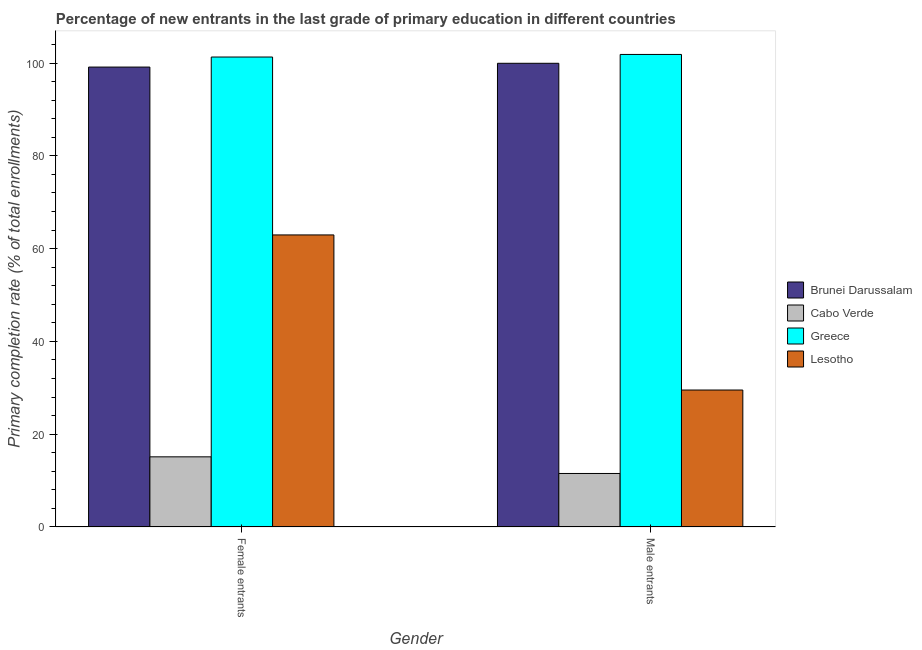How many different coloured bars are there?
Give a very brief answer. 4. How many groups of bars are there?
Provide a succinct answer. 2. How many bars are there on the 1st tick from the left?
Provide a succinct answer. 4. What is the label of the 1st group of bars from the left?
Ensure brevity in your answer.  Female entrants. What is the primary completion rate of female entrants in Greece?
Offer a terse response. 101.31. Across all countries, what is the maximum primary completion rate of female entrants?
Make the answer very short. 101.31. Across all countries, what is the minimum primary completion rate of female entrants?
Offer a very short reply. 15.12. In which country was the primary completion rate of male entrants minimum?
Ensure brevity in your answer.  Cabo Verde. What is the total primary completion rate of female entrants in the graph?
Provide a succinct answer. 278.52. What is the difference between the primary completion rate of male entrants in Greece and that in Cabo Verde?
Your answer should be very brief. 90.32. What is the difference between the primary completion rate of female entrants in Brunei Darussalam and the primary completion rate of male entrants in Lesotho?
Keep it short and to the point. 69.61. What is the average primary completion rate of female entrants per country?
Give a very brief answer. 69.63. What is the difference between the primary completion rate of female entrants and primary completion rate of male entrants in Lesotho?
Your answer should be very brief. 33.43. In how many countries, is the primary completion rate of male entrants greater than 92 %?
Provide a succinct answer. 2. What is the ratio of the primary completion rate of female entrants in Cabo Verde to that in Brunei Darussalam?
Make the answer very short. 0.15. In how many countries, is the primary completion rate of male entrants greater than the average primary completion rate of male entrants taken over all countries?
Your answer should be very brief. 2. What does the 4th bar from the left in Female entrants represents?
Ensure brevity in your answer.  Lesotho. What does the 1st bar from the right in Female entrants represents?
Offer a terse response. Lesotho. Does the graph contain any zero values?
Offer a very short reply. No. Does the graph contain grids?
Provide a succinct answer. No. Where does the legend appear in the graph?
Provide a short and direct response. Center right. How many legend labels are there?
Your response must be concise. 4. What is the title of the graph?
Offer a terse response. Percentage of new entrants in the last grade of primary education in different countries. What is the label or title of the X-axis?
Keep it short and to the point. Gender. What is the label or title of the Y-axis?
Make the answer very short. Primary completion rate (% of total enrollments). What is the Primary completion rate (% of total enrollments) in Brunei Darussalam in Female entrants?
Your response must be concise. 99.14. What is the Primary completion rate (% of total enrollments) of Cabo Verde in Female entrants?
Provide a succinct answer. 15.12. What is the Primary completion rate (% of total enrollments) in Greece in Female entrants?
Give a very brief answer. 101.31. What is the Primary completion rate (% of total enrollments) in Lesotho in Female entrants?
Offer a terse response. 62.96. What is the Primary completion rate (% of total enrollments) in Brunei Darussalam in Male entrants?
Your answer should be very brief. 99.95. What is the Primary completion rate (% of total enrollments) of Cabo Verde in Male entrants?
Keep it short and to the point. 11.54. What is the Primary completion rate (% of total enrollments) in Greece in Male entrants?
Offer a terse response. 101.86. What is the Primary completion rate (% of total enrollments) of Lesotho in Male entrants?
Your response must be concise. 29.53. Across all Gender, what is the maximum Primary completion rate (% of total enrollments) of Brunei Darussalam?
Ensure brevity in your answer.  99.95. Across all Gender, what is the maximum Primary completion rate (% of total enrollments) in Cabo Verde?
Your answer should be very brief. 15.12. Across all Gender, what is the maximum Primary completion rate (% of total enrollments) of Greece?
Keep it short and to the point. 101.86. Across all Gender, what is the maximum Primary completion rate (% of total enrollments) in Lesotho?
Your answer should be compact. 62.96. Across all Gender, what is the minimum Primary completion rate (% of total enrollments) in Brunei Darussalam?
Your answer should be compact. 99.14. Across all Gender, what is the minimum Primary completion rate (% of total enrollments) in Cabo Verde?
Provide a succinct answer. 11.54. Across all Gender, what is the minimum Primary completion rate (% of total enrollments) of Greece?
Your answer should be compact. 101.31. Across all Gender, what is the minimum Primary completion rate (% of total enrollments) of Lesotho?
Offer a very short reply. 29.53. What is the total Primary completion rate (% of total enrollments) in Brunei Darussalam in the graph?
Give a very brief answer. 199.09. What is the total Primary completion rate (% of total enrollments) in Cabo Verde in the graph?
Make the answer very short. 26.66. What is the total Primary completion rate (% of total enrollments) of Greece in the graph?
Provide a short and direct response. 203.16. What is the total Primary completion rate (% of total enrollments) in Lesotho in the graph?
Ensure brevity in your answer.  92.48. What is the difference between the Primary completion rate (% of total enrollments) in Brunei Darussalam in Female entrants and that in Male entrants?
Offer a terse response. -0.82. What is the difference between the Primary completion rate (% of total enrollments) of Cabo Verde in Female entrants and that in Male entrants?
Offer a very short reply. 3.59. What is the difference between the Primary completion rate (% of total enrollments) of Greece in Female entrants and that in Male entrants?
Your answer should be compact. -0.55. What is the difference between the Primary completion rate (% of total enrollments) in Lesotho in Female entrants and that in Male entrants?
Keep it short and to the point. 33.43. What is the difference between the Primary completion rate (% of total enrollments) in Brunei Darussalam in Female entrants and the Primary completion rate (% of total enrollments) in Cabo Verde in Male entrants?
Provide a short and direct response. 87.6. What is the difference between the Primary completion rate (% of total enrollments) of Brunei Darussalam in Female entrants and the Primary completion rate (% of total enrollments) of Greece in Male entrants?
Provide a succinct answer. -2.72. What is the difference between the Primary completion rate (% of total enrollments) of Brunei Darussalam in Female entrants and the Primary completion rate (% of total enrollments) of Lesotho in Male entrants?
Provide a short and direct response. 69.61. What is the difference between the Primary completion rate (% of total enrollments) of Cabo Verde in Female entrants and the Primary completion rate (% of total enrollments) of Greece in Male entrants?
Provide a short and direct response. -86.73. What is the difference between the Primary completion rate (% of total enrollments) in Cabo Verde in Female entrants and the Primary completion rate (% of total enrollments) in Lesotho in Male entrants?
Make the answer very short. -14.4. What is the difference between the Primary completion rate (% of total enrollments) of Greece in Female entrants and the Primary completion rate (% of total enrollments) of Lesotho in Male entrants?
Your response must be concise. 71.78. What is the average Primary completion rate (% of total enrollments) in Brunei Darussalam per Gender?
Your answer should be compact. 99.55. What is the average Primary completion rate (% of total enrollments) in Cabo Verde per Gender?
Offer a very short reply. 13.33. What is the average Primary completion rate (% of total enrollments) in Greece per Gender?
Offer a terse response. 101.58. What is the average Primary completion rate (% of total enrollments) of Lesotho per Gender?
Your answer should be very brief. 46.24. What is the difference between the Primary completion rate (% of total enrollments) of Brunei Darussalam and Primary completion rate (% of total enrollments) of Cabo Verde in Female entrants?
Give a very brief answer. 84.01. What is the difference between the Primary completion rate (% of total enrollments) of Brunei Darussalam and Primary completion rate (% of total enrollments) of Greece in Female entrants?
Your response must be concise. -2.17. What is the difference between the Primary completion rate (% of total enrollments) in Brunei Darussalam and Primary completion rate (% of total enrollments) in Lesotho in Female entrants?
Offer a very short reply. 36.18. What is the difference between the Primary completion rate (% of total enrollments) of Cabo Verde and Primary completion rate (% of total enrollments) of Greece in Female entrants?
Give a very brief answer. -86.18. What is the difference between the Primary completion rate (% of total enrollments) in Cabo Verde and Primary completion rate (% of total enrollments) in Lesotho in Female entrants?
Ensure brevity in your answer.  -47.83. What is the difference between the Primary completion rate (% of total enrollments) of Greece and Primary completion rate (% of total enrollments) of Lesotho in Female entrants?
Ensure brevity in your answer.  38.35. What is the difference between the Primary completion rate (% of total enrollments) in Brunei Darussalam and Primary completion rate (% of total enrollments) in Cabo Verde in Male entrants?
Ensure brevity in your answer.  88.42. What is the difference between the Primary completion rate (% of total enrollments) of Brunei Darussalam and Primary completion rate (% of total enrollments) of Greece in Male entrants?
Make the answer very short. -1.91. What is the difference between the Primary completion rate (% of total enrollments) in Brunei Darussalam and Primary completion rate (% of total enrollments) in Lesotho in Male entrants?
Ensure brevity in your answer.  70.43. What is the difference between the Primary completion rate (% of total enrollments) in Cabo Verde and Primary completion rate (% of total enrollments) in Greece in Male entrants?
Offer a terse response. -90.32. What is the difference between the Primary completion rate (% of total enrollments) in Cabo Verde and Primary completion rate (% of total enrollments) in Lesotho in Male entrants?
Provide a short and direct response. -17.99. What is the difference between the Primary completion rate (% of total enrollments) of Greece and Primary completion rate (% of total enrollments) of Lesotho in Male entrants?
Your answer should be compact. 72.33. What is the ratio of the Primary completion rate (% of total enrollments) of Brunei Darussalam in Female entrants to that in Male entrants?
Your answer should be very brief. 0.99. What is the ratio of the Primary completion rate (% of total enrollments) of Cabo Verde in Female entrants to that in Male entrants?
Ensure brevity in your answer.  1.31. What is the ratio of the Primary completion rate (% of total enrollments) of Greece in Female entrants to that in Male entrants?
Make the answer very short. 0.99. What is the ratio of the Primary completion rate (% of total enrollments) of Lesotho in Female entrants to that in Male entrants?
Make the answer very short. 2.13. What is the difference between the highest and the second highest Primary completion rate (% of total enrollments) of Brunei Darussalam?
Keep it short and to the point. 0.82. What is the difference between the highest and the second highest Primary completion rate (% of total enrollments) of Cabo Verde?
Provide a succinct answer. 3.59. What is the difference between the highest and the second highest Primary completion rate (% of total enrollments) of Greece?
Ensure brevity in your answer.  0.55. What is the difference between the highest and the second highest Primary completion rate (% of total enrollments) of Lesotho?
Provide a succinct answer. 33.43. What is the difference between the highest and the lowest Primary completion rate (% of total enrollments) of Brunei Darussalam?
Offer a terse response. 0.82. What is the difference between the highest and the lowest Primary completion rate (% of total enrollments) in Cabo Verde?
Your response must be concise. 3.59. What is the difference between the highest and the lowest Primary completion rate (% of total enrollments) of Greece?
Keep it short and to the point. 0.55. What is the difference between the highest and the lowest Primary completion rate (% of total enrollments) in Lesotho?
Offer a very short reply. 33.43. 